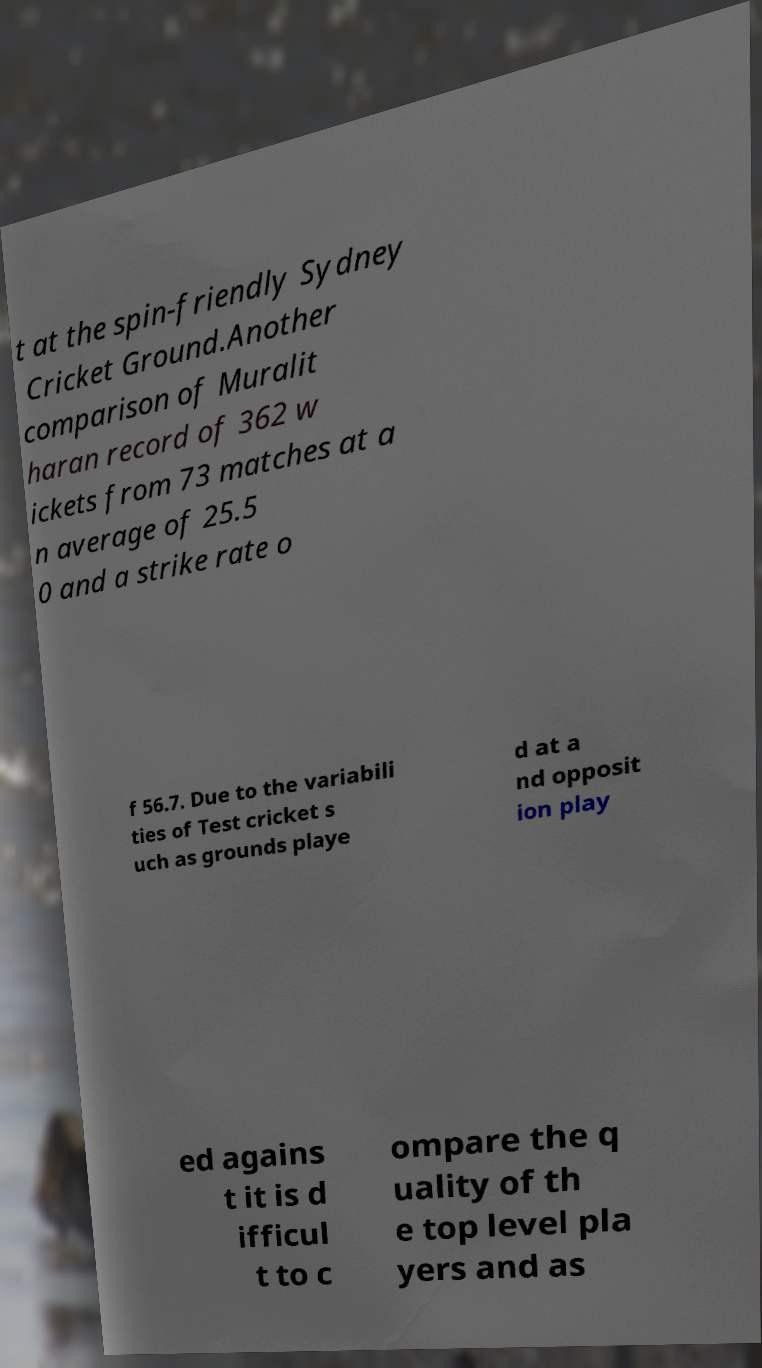Could you extract and type out the text from this image? t at the spin-friendly Sydney Cricket Ground.Another comparison of Muralit haran record of 362 w ickets from 73 matches at a n average of 25.5 0 and a strike rate o f 56.7. Due to the variabili ties of Test cricket s uch as grounds playe d at a nd opposit ion play ed agains t it is d ifficul t to c ompare the q uality of th e top level pla yers and as 